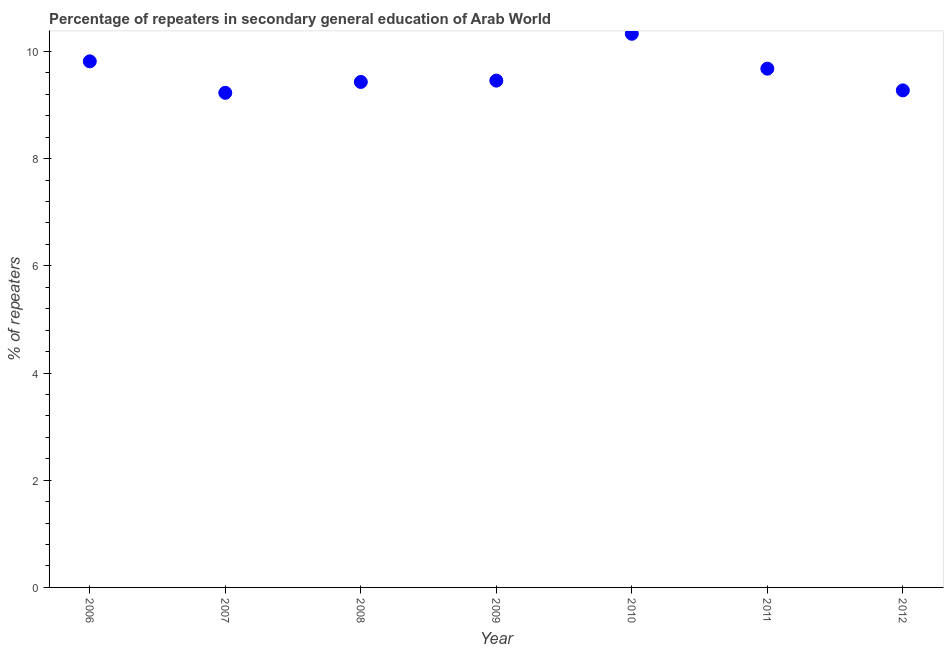What is the percentage of repeaters in 2008?
Ensure brevity in your answer.  9.43. Across all years, what is the maximum percentage of repeaters?
Make the answer very short. 10.33. Across all years, what is the minimum percentage of repeaters?
Provide a short and direct response. 9.23. In which year was the percentage of repeaters maximum?
Your answer should be compact. 2010. In which year was the percentage of repeaters minimum?
Provide a succinct answer. 2007. What is the sum of the percentage of repeaters?
Give a very brief answer. 67.21. What is the difference between the percentage of repeaters in 2008 and 2010?
Your response must be concise. -0.9. What is the average percentage of repeaters per year?
Offer a terse response. 9.6. What is the median percentage of repeaters?
Your response must be concise. 9.46. What is the ratio of the percentage of repeaters in 2009 to that in 2012?
Your response must be concise. 1.02. Is the percentage of repeaters in 2008 less than that in 2010?
Provide a succinct answer. Yes. What is the difference between the highest and the second highest percentage of repeaters?
Keep it short and to the point. 0.51. Is the sum of the percentage of repeaters in 2006 and 2012 greater than the maximum percentage of repeaters across all years?
Ensure brevity in your answer.  Yes. What is the difference between the highest and the lowest percentage of repeaters?
Your answer should be very brief. 1.1. How many dotlines are there?
Make the answer very short. 1. How many years are there in the graph?
Ensure brevity in your answer.  7. What is the difference between two consecutive major ticks on the Y-axis?
Keep it short and to the point. 2. Are the values on the major ticks of Y-axis written in scientific E-notation?
Your answer should be very brief. No. Does the graph contain any zero values?
Keep it short and to the point. No. Does the graph contain grids?
Provide a short and direct response. No. What is the title of the graph?
Ensure brevity in your answer.  Percentage of repeaters in secondary general education of Arab World. What is the label or title of the Y-axis?
Keep it short and to the point. % of repeaters. What is the % of repeaters in 2006?
Give a very brief answer. 9.82. What is the % of repeaters in 2007?
Give a very brief answer. 9.23. What is the % of repeaters in 2008?
Keep it short and to the point. 9.43. What is the % of repeaters in 2009?
Keep it short and to the point. 9.46. What is the % of repeaters in 2010?
Provide a short and direct response. 10.33. What is the % of repeaters in 2011?
Offer a very short reply. 9.68. What is the % of repeaters in 2012?
Offer a terse response. 9.27. What is the difference between the % of repeaters in 2006 and 2007?
Keep it short and to the point. 0.59. What is the difference between the % of repeaters in 2006 and 2008?
Your answer should be compact. 0.38. What is the difference between the % of repeaters in 2006 and 2009?
Your answer should be compact. 0.36. What is the difference between the % of repeaters in 2006 and 2010?
Offer a very short reply. -0.51. What is the difference between the % of repeaters in 2006 and 2011?
Keep it short and to the point. 0.14. What is the difference between the % of repeaters in 2006 and 2012?
Your answer should be compact. 0.54. What is the difference between the % of repeaters in 2007 and 2008?
Offer a terse response. -0.2. What is the difference between the % of repeaters in 2007 and 2009?
Provide a succinct answer. -0.23. What is the difference between the % of repeaters in 2007 and 2010?
Keep it short and to the point. -1.1. What is the difference between the % of repeaters in 2007 and 2011?
Your response must be concise. -0.45. What is the difference between the % of repeaters in 2007 and 2012?
Offer a very short reply. -0.05. What is the difference between the % of repeaters in 2008 and 2009?
Keep it short and to the point. -0.03. What is the difference between the % of repeaters in 2008 and 2010?
Your answer should be compact. -0.9. What is the difference between the % of repeaters in 2008 and 2011?
Offer a terse response. -0.25. What is the difference between the % of repeaters in 2008 and 2012?
Your answer should be very brief. 0.16. What is the difference between the % of repeaters in 2009 and 2010?
Your answer should be very brief. -0.87. What is the difference between the % of repeaters in 2009 and 2011?
Make the answer very short. -0.22. What is the difference between the % of repeaters in 2009 and 2012?
Your answer should be compact. 0.18. What is the difference between the % of repeaters in 2010 and 2011?
Provide a short and direct response. 0.65. What is the difference between the % of repeaters in 2010 and 2012?
Your answer should be compact. 1.06. What is the difference between the % of repeaters in 2011 and 2012?
Provide a succinct answer. 0.41. What is the ratio of the % of repeaters in 2006 to that in 2007?
Your answer should be very brief. 1.06. What is the ratio of the % of repeaters in 2006 to that in 2008?
Keep it short and to the point. 1.04. What is the ratio of the % of repeaters in 2006 to that in 2009?
Offer a very short reply. 1.04. What is the ratio of the % of repeaters in 2006 to that in 2010?
Your answer should be very brief. 0.95. What is the ratio of the % of repeaters in 2006 to that in 2011?
Offer a terse response. 1.01. What is the ratio of the % of repeaters in 2006 to that in 2012?
Provide a short and direct response. 1.06. What is the ratio of the % of repeaters in 2007 to that in 2008?
Ensure brevity in your answer.  0.98. What is the ratio of the % of repeaters in 2007 to that in 2010?
Your answer should be compact. 0.89. What is the ratio of the % of repeaters in 2007 to that in 2011?
Give a very brief answer. 0.95. What is the ratio of the % of repeaters in 2007 to that in 2012?
Keep it short and to the point. 0.99. What is the ratio of the % of repeaters in 2008 to that in 2009?
Keep it short and to the point. 1. What is the ratio of the % of repeaters in 2008 to that in 2010?
Your response must be concise. 0.91. What is the ratio of the % of repeaters in 2008 to that in 2012?
Provide a succinct answer. 1.02. What is the ratio of the % of repeaters in 2009 to that in 2010?
Offer a terse response. 0.92. What is the ratio of the % of repeaters in 2009 to that in 2011?
Make the answer very short. 0.98. What is the ratio of the % of repeaters in 2009 to that in 2012?
Keep it short and to the point. 1.02. What is the ratio of the % of repeaters in 2010 to that in 2011?
Your answer should be compact. 1.07. What is the ratio of the % of repeaters in 2010 to that in 2012?
Offer a very short reply. 1.11. What is the ratio of the % of repeaters in 2011 to that in 2012?
Give a very brief answer. 1.04. 